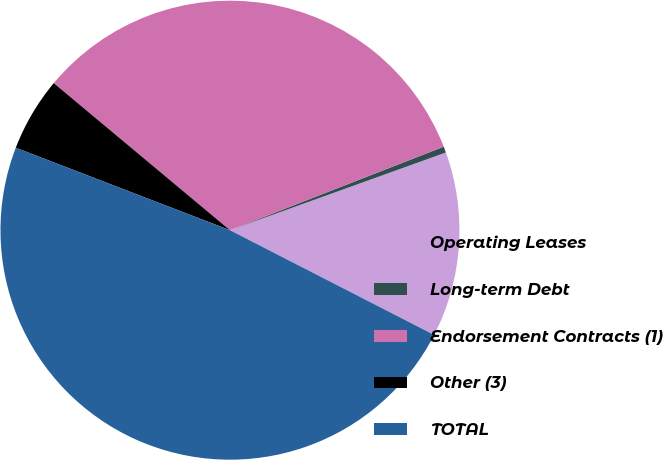Convert chart. <chart><loc_0><loc_0><loc_500><loc_500><pie_chart><fcel>Operating Leases<fcel>Long-term Debt<fcel>Endorsement Contracts (1)<fcel>Other (3)<fcel>TOTAL<nl><fcel>13.04%<fcel>0.43%<fcel>33.0%<fcel>5.22%<fcel>48.3%<nl></chart> 